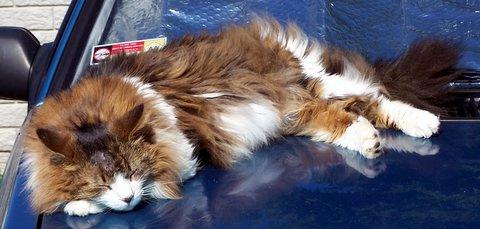What animal is this?
Write a very short answer. Cat. What is the cat sleeping on?
Answer briefly. Car. Is the car blue?
Write a very short answer. Yes. 